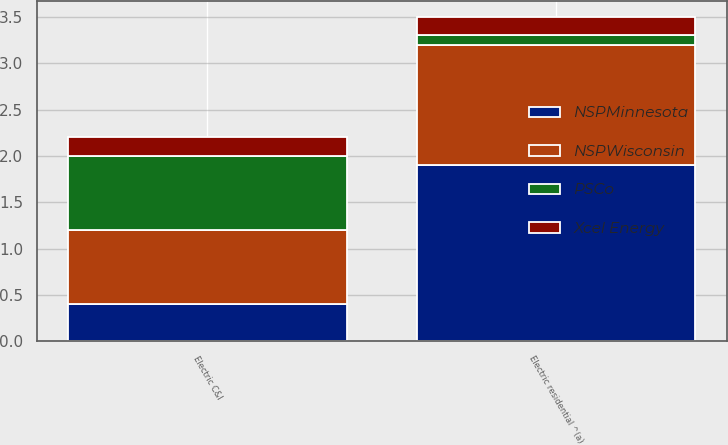<chart> <loc_0><loc_0><loc_500><loc_500><stacked_bar_chart><ecel><fcel>Electric residential ^(a)<fcel>Electric C&I<nl><fcel>PSCo<fcel>0.1<fcel>0.8<nl><fcel>NSPMinnesota<fcel>1.9<fcel>0.4<nl><fcel>NSPWisconsin<fcel>1.3<fcel>0.8<nl><fcel>Xcel Energy<fcel>0.2<fcel>0.2<nl></chart> 